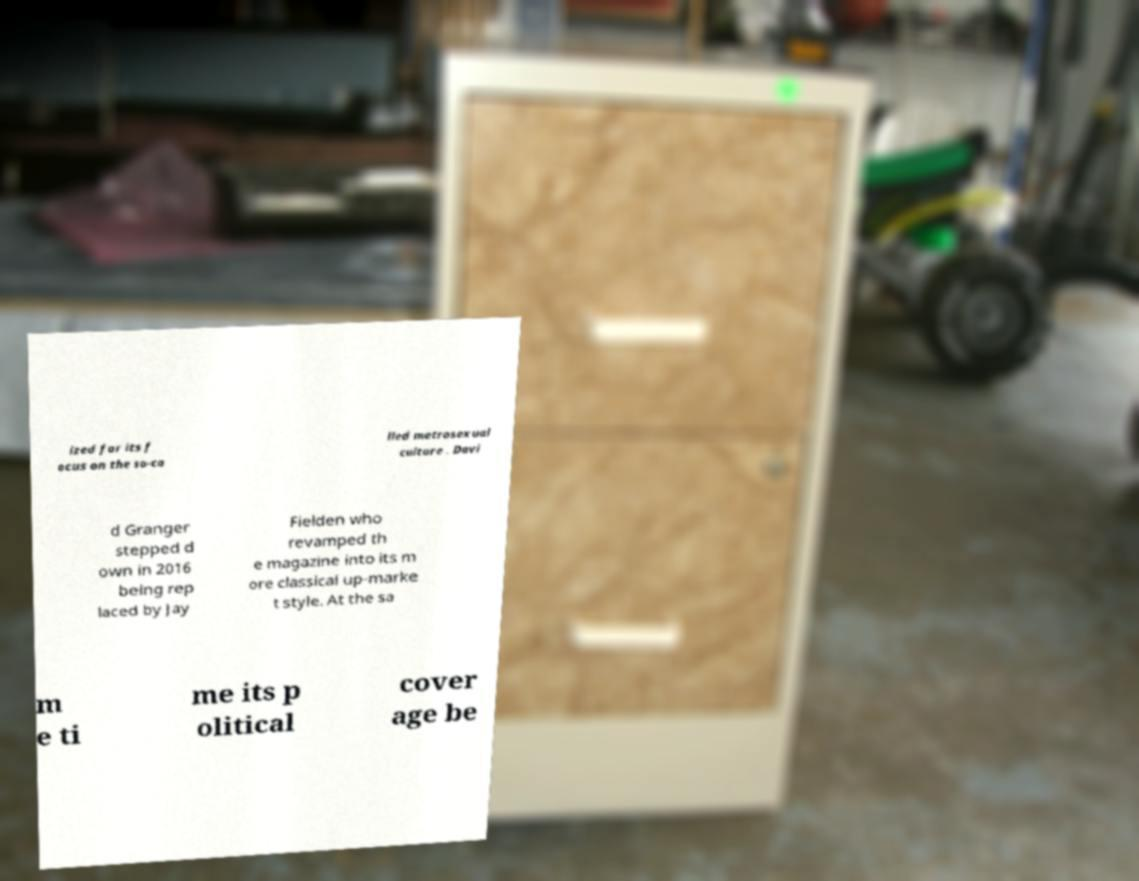Please identify and transcribe the text found in this image. ized for its f ocus on the so-ca lled metrosexual culture . Davi d Granger stepped d own in 2016 being rep laced by Jay Fielden who revamped th e magazine into its m ore classical up-marke t style. At the sa m e ti me its p olitical cover age be 